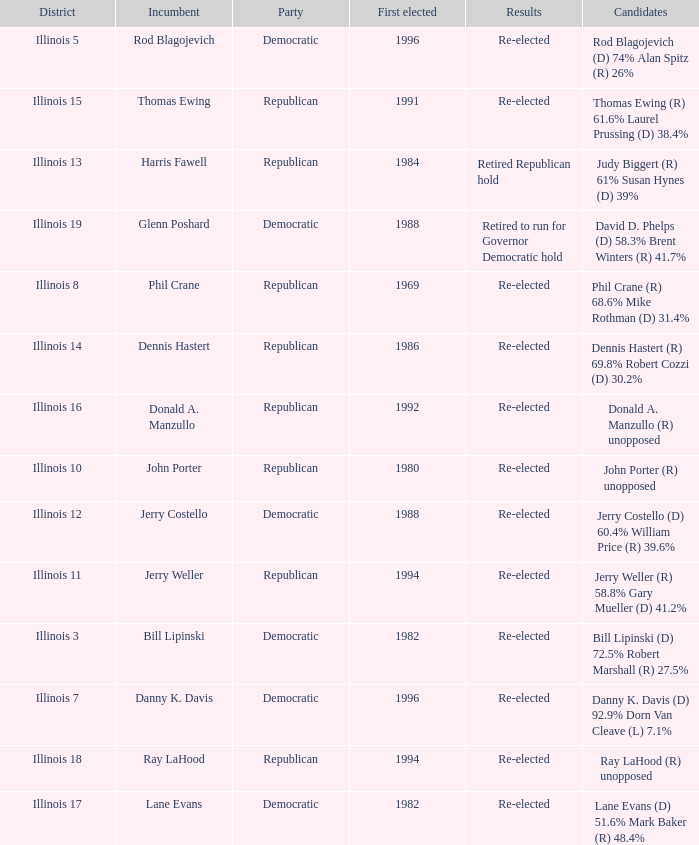Who were the candidates in the district where Jerry Costello won? Jerry Costello (D) 60.4% William Price (R) 39.6%. 